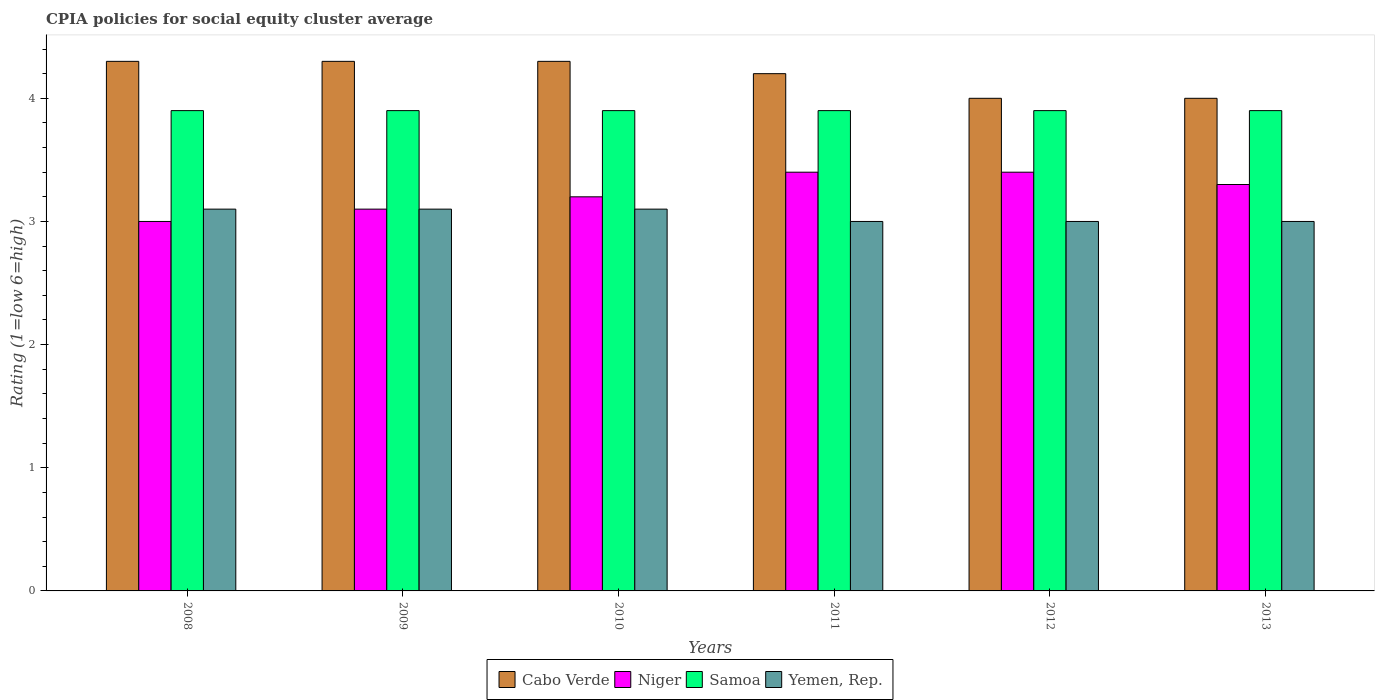How many different coloured bars are there?
Provide a short and direct response. 4. How many groups of bars are there?
Your response must be concise. 6. How many bars are there on the 1st tick from the left?
Make the answer very short. 4. What is the label of the 4th group of bars from the left?
Keep it short and to the point. 2011. What is the CPIA rating in Samoa in 2010?
Offer a very short reply. 3.9. In which year was the CPIA rating in Yemen, Rep. maximum?
Your answer should be very brief. 2008. In which year was the CPIA rating in Cabo Verde minimum?
Provide a succinct answer. 2012. What is the total CPIA rating in Cabo Verde in the graph?
Your response must be concise. 25.1. What is the difference between the CPIA rating in Yemen, Rep. in 2010 and that in 2013?
Provide a succinct answer. 0.1. What is the difference between the CPIA rating in Yemen, Rep. in 2008 and the CPIA rating in Cabo Verde in 2013?
Offer a very short reply. -0.9. What is the average CPIA rating in Niger per year?
Your response must be concise. 3.23. In the year 2009, what is the difference between the CPIA rating in Cabo Verde and CPIA rating in Yemen, Rep.?
Make the answer very short. 1.2. What is the difference between the highest and the lowest CPIA rating in Yemen, Rep.?
Your answer should be very brief. 0.1. In how many years, is the CPIA rating in Niger greater than the average CPIA rating in Niger taken over all years?
Provide a short and direct response. 3. Is the sum of the CPIA rating in Niger in 2008 and 2011 greater than the maximum CPIA rating in Samoa across all years?
Offer a terse response. Yes. Is it the case that in every year, the sum of the CPIA rating in Cabo Verde and CPIA rating in Samoa is greater than the sum of CPIA rating in Yemen, Rep. and CPIA rating in Niger?
Your response must be concise. Yes. What does the 2nd bar from the left in 2011 represents?
Give a very brief answer. Niger. What does the 3rd bar from the right in 2008 represents?
Provide a short and direct response. Niger. Are all the bars in the graph horizontal?
Give a very brief answer. No. How many years are there in the graph?
Ensure brevity in your answer.  6. What is the difference between two consecutive major ticks on the Y-axis?
Your answer should be compact. 1. Does the graph contain any zero values?
Give a very brief answer. No. Where does the legend appear in the graph?
Keep it short and to the point. Bottom center. What is the title of the graph?
Your answer should be very brief. CPIA policies for social equity cluster average. Does "Bolivia" appear as one of the legend labels in the graph?
Provide a short and direct response. No. What is the label or title of the X-axis?
Your response must be concise. Years. What is the label or title of the Y-axis?
Make the answer very short. Rating (1=low 6=high). What is the Rating (1=low 6=high) of Cabo Verde in 2008?
Your answer should be compact. 4.3. What is the Rating (1=low 6=high) in Samoa in 2008?
Provide a succinct answer. 3.9. What is the Rating (1=low 6=high) of Yemen, Rep. in 2008?
Provide a short and direct response. 3.1. What is the Rating (1=low 6=high) in Cabo Verde in 2009?
Your response must be concise. 4.3. What is the Rating (1=low 6=high) of Niger in 2009?
Give a very brief answer. 3.1. What is the Rating (1=low 6=high) in Samoa in 2009?
Your answer should be very brief. 3.9. What is the Rating (1=low 6=high) of Yemen, Rep. in 2009?
Your answer should be compact. 3.1. What is the Rating (1=low 6=high) in Samoa in 2010?
Your response must be concise. 3.9. What is the Rating (1=low 6=high) of Cabo Verde in 2011?
Offer a very short reply. 4.2. What is the Rating (1=low 6=high) of Samoa in 2011?
Your answer should be very brief. 3.9. What is the Rating (1=low 6=high) of Yemen, Rep. in 2012?
Offer a terse response. 3. What is the Rating (1=low 6=high) in Cabo Verde in 2013?
Your answer should be very brief. 4. What is the Rating (1=low 6=high) of Niger in 2013?
Give a very brief answer. 3.3. What is the Rating (1=low 6=high) of Samoa in 2013?
Your answer should be compact. 3.9. Across all years, what is the maximum Rating (1=low 6=high) of Cabo Verde?
Keep it short and to the point. 4.3. Across all years, what is the maximum Rating (1=low 6=high) in Samoa?
Offer a terse response. 3.9. Across all years, what is the maximum Rating (1=low 6=high) of Yemen, Rep.?
Provide a short and direct response. 3.1. Across all years, what is the minimum Rating (1=low 6=high) of Niger?
Offer a very short reply. 3. Across all years, what is the minimum Rating (1=low 6=high) of Samoa?
Provide a succinct answer. 3.9. Across all years, what is the minimum Rating (1=low 6=high) of Yemen, Rep.?
Keep it short and to the point. 3. What is the total Rating (1=low 6=high) of Cabo Verde in the graph?
Offer a terse response. 25.1. What is the total Rating (1=low 6=high) of Samoa in the graph?
Offer a very short reply. 23.4. What is the total Rating (1=low 6=high) in Yemen, Rep. in the graph?
Offer a terse response. 18.3. What is the difference between the Rating (1=low 6=high) in Cabo Verde in 2008 and that in 2009?
Offer a terse response. 0. What is the difference between the Rating (1=low 6=high) of Niger in 2008 and that in 2009?
Your answer should be very brief. -0.1. What is the difference between the Rating (1=low 6=high) of Yemen, Rep. in 2008 and that in 2009?
Ensure brevity in your answer.  0. What is the difference between the Rating (1=low 6=high) in Cabo Verde in 2008 and that in 2010?
Offer a very short reply. 0. What is the difference between the Rating (1=low 6=high) of Yemen, Rep. in 2008 and that in 2010?
Provide a succinct answer. 0. What is the difference between the Rating (1=low 6=high) in Niger in 2008 and that in 2011?
Provide a short and direct response. -0.4. What is the difference between the Rating (1=low 6=high) of Niger in 2008 and that in 2012?
Ensure brevity in your answer.  -0.4. What is the difference between the Rating (1=low 6=high) in Yemen, Rep. in 2008 and that in 2012?
Provide a succinct answer. 0.1. What is the difference between the Rating (1=low 6=high) of Niger in 2008 and that in 2013?
Offer a terse response. -0.3. What is the difference between the Rating (1=low 6=high) in Yemen, Rep. in 2008 and that in 2013?
Your answer should be very brief. 0.1. What is the difference between the Rating (1=low 6=high) in Niger in 2009 and that in 2010?
Your response must be concise. -0.1. What is the difference between the Rating (1=low 6=high) of Samoa in 2009 and that in 2010?
Your response must be concise. 0. What is the difference between the Rating (1=low 6=high) in Cabo Verde in 2009 and that in 2011?
Offer a terse response. 0.1. What is the difference between the Rating (1=low 6=high) in Niger in 2009 and that in 2011?
Provide a succinct answer. -0.3. What is the difference between the Rating (1=low 6=high) of Samoa in 2009 and that in 2011?
Keep it short and to the point. 0. What is the difference between the Rating (1=low 6=high) in Yemen, Rep. in 2009 and that in 2011?
Give a very brief answer. 0.1. What is the difference between the Rating (1=low 6=high) in Samoa in 2009 and that in 2012?
Your answer should be very brief. 0. What is the difference between the Rating (1=low 6=high) in Niger in 2009 and that in 2013?
Ensure brevity in your answer.  -0.2. What is the difference between the Rating (1=low 6=high) in Samoa in 2009 and that in 2013?
Provide a short and direct response. 0. What is the difference between the Rating (1=low 6=high) in Cabo Verde in 2010 and that in 2011?
Provide a succinct answer. 0.1. What is the difference between the Rating (1=low 6=high) in Yemen, Rep. in 2010 and that in 2011?
Provide a succinct answer. 0.1. What is the difference between the Rating (1=low 6=high) of Niger in 2010 and that in 2012?
Provide a succinct answer. -0.2. What is the difference between the Rating (1=low 6=high) in Niger in 2010 and that in 2013?
Ensure brevity in your answer.  -0.1. What is the difference between the Rating (1=low 6=high) of Yemen, Rep. in 2010 and that in 2013?
Your answer should be compact. 0.1. What is the difference between the Rating (1=low 6=high) in Samoa in 2011 and that in 2012?
Offer a very short reply. 0. What is the difference between the Rating (1=low 6=high) of Yemen, Rep. in 2011 and that in 2012?
Your answer should be very brief. 0. What is the difference between the Rating (1=low 6=high) in Cabo Verde in 2011 and that in 2013?
Provide a short and direct response. 0.2. What is the difference between the Rating (1=low 6=high) of Yemen, Rep. in 2011 and that in 2013?
Make the answer very short. 0. What is the difference between the Rating (1=low 6=high) in Niger in 2012 and that in 2013?
Offer a very short reply. 0.1. What is the difference between the Rating (1=low 6=high) of Samoa in 2012 and that in 2013?
Offer a very short reply. 0. What is the difference between the Rating (1=low 6=high) in Yemen, Rep. in 2012 and that in 2013?
Ensure brevity in your answer.  0. What is the difference between the Rating (1=low 6=high) in Cabo Verde in 2008 and the Rating (1=low 6=high) in Niger in 2009?
Make the answer very short. 1.2. What is the difference between the Rating (1=low 6=high) of Niger in 2008 and the Rating (1=low 6=high) of Yemen, Rep. in 2009?
Your answer should be compact. -0.1. What is the difference between the Rating (1=low 6=high) of Cabo Verde in 2008 and the Rating (1=low 6=high) of Samoa in 2010?
Provide a succinct answer. 0.4. What is the difference between the Rating (1=low 6=high) of Cabo Verde in 2008 and the Rating (1=low 6=high) of Yemen, Rep. in 2010?
Your response must be concise. 1.2. What is the difference between the Rating (1=low 6=high) in Niger in 2008 and the Rating (1=low 6=high) in Samoa in 2010?
Your response must be concise. -0.9. What is the difference between the Rating (1=low 6=high) in Cabo Verde in 2008 and the Rating (1=low 6=high) in Niger in 2011?
Your answer should be compact. 0.9. What is the difference between the Rating (1=low 6=high) in Cabo Verde in 2008 and the Rating (1=low 6=high) in Samoa in 2011?
Your answer should be compact. 0.4. What is the difference between the Rating (1=low 6=high) of Cabo Verde in 2008 and the Rating (1=low 6=high) of Yemen, Rep. in 2011?
Make the answer very short. 1.3. What is the difference between the Rating (1=low 6=high) in Niger in 2008 and the Rating (1=low 6=high) in Samoa in 2011?
Offer a terse response. -0.9. What is the difference between the Rating (1=low 6=high) in Niger in 2008 and the Rating (1=low 6=high) in Yemen, Rep. in 2011?
Offer a terse response. 0. What is the difference between the Rating (1=low 6=high) of Cabo Verde in 2008 and the Rating (1=low 6=high) of Niger in 2012?
Ensure brevity in your answer.  0.9. What is the difference between the Rating (1=low 6=high) of Cabo Verde in 2008 and the Rating (1=low 6=high) of Yemen, Rep. in 2012?
Your response must be concise. 1.3. What is the difference between the Rating (1=low 6=high) in Niger in 2008 and the Rating (1=low 6=high) in Samoa in 2012?
Your answer should be very brief. -0.9. What is the difference between the Rating (1=low 6=high) of Niger in 2008 and the Rating (1=low 6=high) of Yemen, Rep. in 2012?
Your answer should be compact. 0. What is the difference between the Rating (1=low 6=high) of Cabo Verde in 2008 and the Rating (1=low 6=high) of Niger in 2013?
Ensure brevity in your answer.  1. What is the difference between the Rating (1=low 6=high) in Niger in 2008 and the Rating (1=low 6=high) in Samoa in 2013?
Ensure brevity in your answer.  -0.9. What is the difference between the Rating (1=low 6=high) of Niger in 2008 and the Rating (1=low 6=high) of Yemen, Rep. in 2013?
Offer a very short reply. 0. What is the difference between the Rating (1=low 6=high) in Samoa in 2008 and the Rating (1=low 6=high) in Yemen, Rep. in 2013?
Offer a terse response. 0.9. What is the difference between the Rating (1=low 6=high) of Cabo Verde in 2009 and the Rating (1=low 6=high) of Niger in 2010?
Offer a terse response. 1.1. What is the difference between the Rating (1=low 6=high) in Cabo Verde in 2009 and the Rating (1=low 6=high) in Samoa in 2010?
Give a very brief answer. 0.4. What is the difference between the Rating (1=low 6=high) of Niger in 2009 and the Rating (1=low 6=high) of Samoa in 2010?
Give a very brief answer. -0.8. What is the difference between the Rating (1=low 6=high) of Niger in 2009 and the Rating (1=low 6=high) of Yemen, Rep. in 2010?
Your answer should be very brief. 0. What is the difference between the Rating (1=low 6=high) of Samoa in 2009 and the Rating (1=low 6=high) of Yemen, Rep. in 2010?
Keep it short and to the point. 0.8. What is the difference between the Rating (1=low 6=high) of Cabo Verde in 2009 and the Rating (1=low 6=high) of Niger in 2011?
Provide a short and direct response. 0.9. What is the difference between the Rating (1=low 6=high) of Cabo Verde in 2009 and the Rating (1=low 6=high) of Samoa in 2011?
Provide a short and direct response. 0.4. What is the difference between the Rating (1=low 6=high) in Samoa in 2009 and the Rating (1=low 6=high) in Yemen, Rep. in 2011?
Your answer should be very brief. 0.9. What is the difference between the Rating (1=low 6=high) in Cabo Verde in 2009 and the Rating (1=low 6=high) in Niger in 2012?
Your response must be concise. 0.9. What is the difference between the Rating (1=low 6=high) in Cabo Verde in 2009 and the Rating (1=low 6=high) in Yemen, Rep. in 2012?
Offer a terse response. 1.3. What is the difference between the Rating (1=low 6=high) of Samoa in 2009 and the Rating (1=low 6=high) of Yemen, Rep. in 2012?
Provide a short and direct response. 0.9. What is the difference between the Rating (1=low 6=high) of Cabo Verde in 2009 and the Rating (1=low 6=high) of Niger in 2013?
Your answer should be very brief. 1. What is the difference between the Rating (1=low 6=high) of Cabo Verde in 2009 and the Rating (1=low 6=high) of Yemen, Rep. in 2013?
Your answer should be compact. 1.3. What is the difference between the Rating (1=low 6=high) in Cabo Verde in 2010 and the Rating (1=low 6=high) in Niger in 2011?
Ensure brevity in your answer.  0.9. What is the difference between the Rating (1=low 6=high) of Niger in 2010 and the Rating (1=low 6=high) of Samoa in 2011?
Keep it short and to the point. -0.7. What is the difference between the Rating (1=low 6=high) in Niger in 2010 and the Rating (1=low 6=high) in Yemen, Rep. in 2012?
Your answer should be very brief. 0.2. What is the difference between the Rating (1=low 6=high) in Samoa in 2010 and the Rating (1=low 6=high) in Yemen, Rep. in 2012?
Offer a terse response. 0.9. What is the difference between the Rating (1=low 6=high) of Cabo Verde in 2010 and the Rating (1=low 6=high) of Niger in 2013?
Offer a terse response. 1. What is the difference between the Rating (1=low 6=high) in Cabo Verde in 2010 and the Rating (1=low 6=high) in Samoa in 2013?
Give a very brief answer. 0.4. What is the difference between the Rating (1=low 6=high) in Cabo Verde in 2011 and the Rating (1=low 6=high) in Niger in 2012?
Give a very brief answer. 0.8. What is the difference between the Rating (1=low 6=high) of Cabo Verde in 2011 and the Rating (1=low 6=high) of Samoa in 2012?
Keep it short and to the point. 0.3. What is the difference between the Rating (1=low 6=high) in Niger in 2011 and the Rating (1=low 6=high) in Samoa in 2012?
Give a very brief answer. -0.5. What is the difference between the Rating (1=low 6=high) of Niger in 2011 and the Rating (1=low 6=high) of Yemen, Rep. in 2012?
Offer a very short reply. 0.4. What is the difference between the Rating (1=low 6=high) of Cabo Verde in 2011 and the Rating (1=low 6=high) of Niger in 2013?
Provide a succinct answer. 0.9. What is the difference between the Rating (1=low 6=high) of Niger in 2011 and the Rating (1=low 6=high) of Samoa in 2013?
Provide a short and direct response. -0.5. What is the difference between the Rating (1=low 6=high) of Niger in 2011 and the Rating (1=low 6=high) of Yemen, Rep. in 2013?
Provide a short and direct response. 0.4. What is the difference between the Rating (1=low 6=high) in Cabo Verde in 2012 and the Rating (1=low 6=high) in Samoa in 2013?
Make the answer very short. 0.1. What is the difference between the Rating (1=low 6=high) in Niger in 2012 and the Rating (1=low 6=high) in Samoa in 2013?
Provide a short and direct response. -0.5. What is the difference between the Rating (1=low 6=high) in Niger in 2012 and the Rating (1=low 6=high) in Yemen, Rep. in 2013?
Ensure brevity in your answer.  0.4. What is the average Rating (1=low 6=high) of Cabo Verde per year?
Your answer should be very brief. 4.18. What is the average Rating (1=low 6=high) in Niger per year?
Your answer should be very brief. 3.23. What is the average Rating (1=low 6=high) in Samoa per year?
Make the answer very short. 3.9. What is the average Rating (1=low 6=high) in Yemen, Rep. per year?
Provide a succinct answer. 3.05. In the year 2008, what is the difference between the Rating (1=low 6=high) in Cabo Verde and Rating (1=low 6=high) in Samoa?
Make the answer very short. 0.4. In the year 2008, what is the difference between the Rating (1=low 6=high) in Cabo Verde and Rating (1=low 6=high) in Yemen, Rep.?
Your answer should be compact. 1.2. In the year 2008, what is the difference between the Rating (1=low 6=high) in Niger and Rating (1=low 6=high) in Yemen, Rep.?
Give a very brief answer. -0.1. In the year 2008, what is the difference between the Rating (1=low 6=high) of Samoa and Rating (1=low 6=high) of Yemen, Rep.?
Make the answer very short. 0.8. In the year 2009, what is the difference between the Rating (1=low 6=high) of Cabo Verde and Rating (1=low 6=high) of Niger?
Provide a short and direct response. 1.2. In the year 2009, what is the difference between the Rating (1=low 6=high) of Cabo Verde and Rating (1=low 6=high) of Samoa?
Make the answer very short. 0.4. In the year 2009, what is the difference between the Rating (1=low 6=high) in Cabo Verde and Rating (1=low 6=high) in Yemen, Rep.?
Ensure brevity in your answer.  1.2. In the year 2010, what is the difference between the Rating (1=low 6=high) of Cabo Verde and Rating (1=low 6=high) of Niger?
Provide a succinct answer. 1.1. In the year 2010, what is the difference between the Rating (1=low 6=high) of Samoa and Rating (1=low 6=high) of Yemen, Rep.?
Your answer should be very brief. 0.8. In the year 2011, what is the difference between the Rating (1=low 6=high) in Cabo Verde and Rating (1=low 6=high) in Samoa?
Keep it short and to the point. 0.3. In the year 2012, what is the difference between the Rating (1=low 6=high) of Cabo Verde and Rating (1=low 6=high) of Niger?
Your response must be concise. 0.6. In the year 2012, what is the difference between the Rating (1=low 6=high) of Cabo Verde and Rating (1=low 6=high) of Samoa?
Provide a short and direct response. 0.1. In the year 2012, what is the difference between the Rating (1=low 6=high) of Niger and Rating (1=low 6=high) of Samoa?
Provide a succinct answer. -0.5. In the year 2012, what is the difference between the Rating (1=low 6=high) of Niger and Rating (1=low 6=high) of Yemen, Rep.?
Make the answer very short. 0.4. In the year 2013, what is the difference between the Rating (1=low 6=high) in Cabo Verde and Rating (1=low 6=high) in Niger?
Make the answer very short. 0.7. In the year 2013, what is the difference between the Rating (1=low 6=high) of Niger and Rating (1=low 6=high) of Samoa?
Ensure brevity in your answer.  -0.6. What is the ratio of the Rating (1=low 6=high) in Cabo Verde in 2008 to that in 2009?
Offer a very short reply. 1. What is the ratio of the Rating (1=low 6=high) in Samoa in 2008 to that in 2009?
Provide a short and direct response. 1. What is the ratio of the Rating (1=low 6=high) of Niger in 2008 to that in 2010?
Your response must be concise. 0.94. What is the ratio of the Rating (1=low 6=high) in Samoa in 2008 to that in 2010?
Provide a succinct answer. 1. What is the ratio of the Rating (1=low 6=high) of Cabo Verde in 2008 to that in 2011?
Give a very brief answer. 1.02. What is the ratio of the Rating (1=low 6=high) in Niger in 2008 to that in 2011?
Keep it short and to the point. 0.88. What is the ratio of the Rating (1=low 6=high) in Samoa in 2008 to that in 2011?
Give a very brief answer. 1. What is the ratio of the Rating (1=low 6=high) of Cabo Verde in 2008 to that in 2012?
Provide a succinct answer. 1.07. What is the ratio of the Rating (1=low 6=high) of Niger in 2008 to that in 2012?
Offer a very short reply. 0.88. What is the ratio of the Rating (1=low 6=high) of Samoa in 2008 to that in 2012?
Offer a very short reply. 1. What is the ratio of the Rating (1=low 6=high) in Cabo Verde in 2008 to that in 2013?
Your answer should be compact. 1.07. What is the ratio of the Rating (1=low 6=high) in Niger in 2008 to that in 2013?
Make the answer very short. 0.91. What is the ratio of the Rating (1=low 6=high) of Samoa in 2008 to that in 2013?
Keep it short and to the point. 1. What is the ratio of the Rating (1=low 6=high) in Yemen, Rep. in 2008 to that in 2013?
Give a very brief answer. 1.03. What is the ratio of the Rating (1=low 6=high) of Cabo Verde in 2009 to that in 2010?
Give a very brief answer. 1. What is the ratio of the Rating (1=low 6=high) in Niger in 2009 to that in 2010?
Your answer should be very brief. 0.97. What is the ratio of the Rating (1=low 6=high) in Yemen, Rep. in 2009 to that in 2010?
Keep it short and to the point. 1. What is the ratio of the Rating (1=low 6=high) of Cabo Verde in 2009 to that in 2011?
Provide a short and direct response. 1.02. What is the ratio of the Rating (1=low 6=high) in Niger in 2009 to that in 2011?
Your answer should be very brief. 0.91. What is the ratio of the Rating (1=low 6=high) of Yemen, Rep. in 2009 to that in 2011?
Provide a short and direct response. 1.03. What is the ratio of the Rating (1=low 6=high) of Cabo Verde in 2009 to that in 2012?
Make the answer very short. 1.07. What is the ratio of the Rating (1=low 6=high) of Niger in 2009 to that in 2012?
Your answer should be compact. 0.91. What is the ratio of the Rating (1=low 6=high) in Cabo Verde in 2009 to that in 2013?
Make the answer very short. 1.07. What is the ratio of the Rating (1=low 6=high) in Niger in 2009 to that in 2013?
Your answer should be very brief. 0.94. What is the ratio of the Rating (1=low 6=high) in Cabo Verde in 2010 to that in 2011?
Provide a short and direct response. 1.02. What is the ratio of the Rating (1=low 6=high) of Niger in 2010 to that in 2011?
Keep it short and to the point. 0.94. What is the ratio of the Rating (1=low 6=high) in Samoa in 2010 to that in 2011?
Provide a succinct answer. 1. What is the ratio of the Rating (1=low 6=high) in Yemen, Rep. in 2010 to that in 2011?
Give a very brief answer. 1.03. What is the ratio of the Rating (1=low 6=high) in Cabo Verde in 2010 to that in 2012?
Offer a terse response. 1.07. What is the ratio of the Rating (1=low 6=high) in Niger in 2010 to that in 2012?
Your answer should be very brief. 0.94. What is the ratio of the Rating (1=low 6=high) of Samoa in 2010 to that in 2012?
Ensure brevity in your answer.  1. What is the ratio of the Rating (1=low 6=high) of Yemen, Rep. in 2010 to that in 2012?
Ensure brevity in your answer.  1.03. What is the ratio of the Rating (1=low 6=high) of Cabo Verde in 2010 to that in 2013?
Ensure brevity in your answer.  1.07. What is the ratio of the Rating (1=low 6=high) in Niger in 2010 to that in 2013?
Ensure brevity in your answer.  0.97. What is the ratio of the Rating (1=low 6=high) in Samoa in 2011 to that in 2012?
Offer a very short reply. 1. What is the ratio of the Rating (1=low 6=high) of Yemen, Rep. in 2011 to that in 2012?
Offer a terse response. 1. What is the ratio of the Rating (1=low 6=high) in Niger in 2011 to that in 2013?
Provide a short and direct response. 1.03. What is the ratio of the Rating (1=low 6=high) in Samoa in 2011 to that in 2013?
Offer a very short reply. 1. What is the ratio of the Rating (1=low 6=high) of Yemen, Rep. in 2011 to that in 2013?
Provide a succinct answer. 1. What is the ratio of the Rating (1=low 6=high) of Cabo Verde in 2012 to that in 2013?
Make the answer very short. 1. What is the ratio of the Rating (1=low 6=high) of Niger in 2012 to that in 2013?
Give a very brief answer. 1.03. What is the ratio of the Rating (1=low 6=high) in Yemen, Rep. in 2012 to that in 2013?
Give a very brief answer. 1. What is the difference between the highest and the lowest Rating (1=low 6=high) of Cabo Verde?
Provide a succinct answer. 0.3. What is the difference between the highest and the lowest Rating (1=low 6=high) in Samoa?
Provide a succinct answer. 0. 